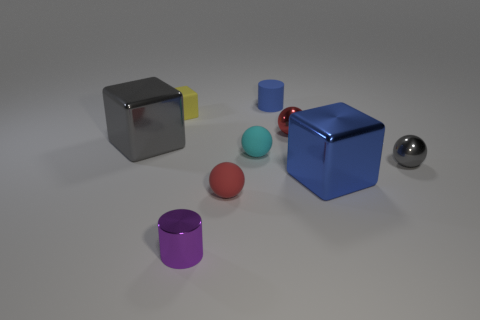Does the small purple cylinder have the same material as the small cyan object?
Offer a terse response. No. What number of cyan objects have the same shape as the large gray thing?
Offer a terse response. 0. There is a blue thing that is the same material as the small purple cylinder; what shape is it?
Provide a succinct answer. Cube. There is a cube that is behind the block that is on the left side of the small rubber cube; what is its color?
Offer a very short reply. Yellow. Is the tiny matte cylinder the same color as the tiny rubber cube?
Make the answer very short. No. What material is the block that is in front of the large shiny object that is to the left of the small metal cylinder?
Ensure brevity in your answer.  Metal. There is a gray thing that is the same shape as the yellow object; what material is it?
Keep it short and to the point. Metal. Are there any small metal things that are to the left of the small metallic ball in front of the gray object that is left of the blue cylinder?
Give a very brief answer. Yes. How many other things are the same color as the small matte block?
Ensure brevity in your answer.  0. How many metal spheres are behind the small gray sphere and in front of the tiny red metal thing?
Your response must be concise. 0. 